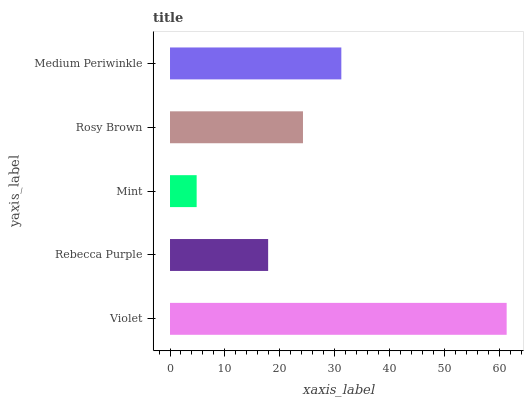Is Mint the minimum?
Answer yes or no. Yes. Is Violet the maximum?
Answer yes or no. Yes. Is Rebecca Purple the minimum?
Answer yes or no. No. Is Rebecca Purple the maximum?
Answer yes or no. No. Is Violet greater than Rebecca Purple?
Answer yes or no. Yes. Is Rebecca Purple less than Violet?
Answer yes or no. Yes. Is Rebecca Purple greater than Violet?
Answer yes or no. No. Is Violet less than Rebecca Purple?
Answer yes or no. No. Is Rosy Brown the high median?
Answer yes or no. Yes. Is Rosy Brown the low median?
Answer yes or no. Yes. Is Violet the high median?
Answer yes or no. No. Is Mint the low median?
Answer yes or no. No. 